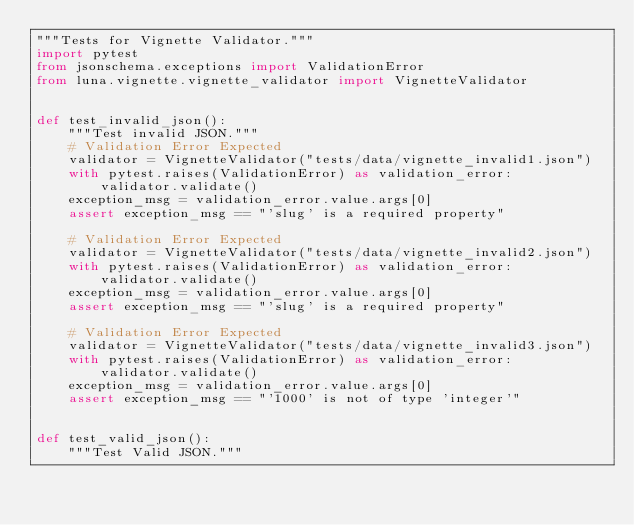Convert code to text. <code><loc_0><loc_0><loc_500><loc_500><_Python_>"""Tests for Vignette Validator."""
import pytest
from jsonschema.exceptions import ValidationError
from luna.vignette.vignette_validator import VignetteValidator


def test_invalid_json():
    """Test invalid JSON."""
    # Validation Error Expected
    validator = VignetteValidator("tests/data/vignette_invalid1.json")
    with pytest.raises(ValidationError) as validation_error:
        validator.validate()
    exception_msg = validation_error.value.args[0]
    assert exception_msg == "'slug' is a required property"

    # Validation Error Expected
    validator = VignetteValidator("tests/data/vignette_invalid2.json")
    with pytest.raises(ValidationError) as validation_error:
        validator.validate()
    exception_msg = validation_error.value.args[0]
    assert exception_msg == "'slug' is a required property"

    # Validation Error Expected
    validator = VignetteValidator("tests/data/vignette_invalid3.json")
    with pytest.raises(ValidationError) as validation_error:
        validator.validate()
    exception_msg = validation_error.value.args[0]
    assert exception_msg == "'1000' is not of type 'integer'"


def test_valid_json():
    """Test Valid JSON."""</code> 